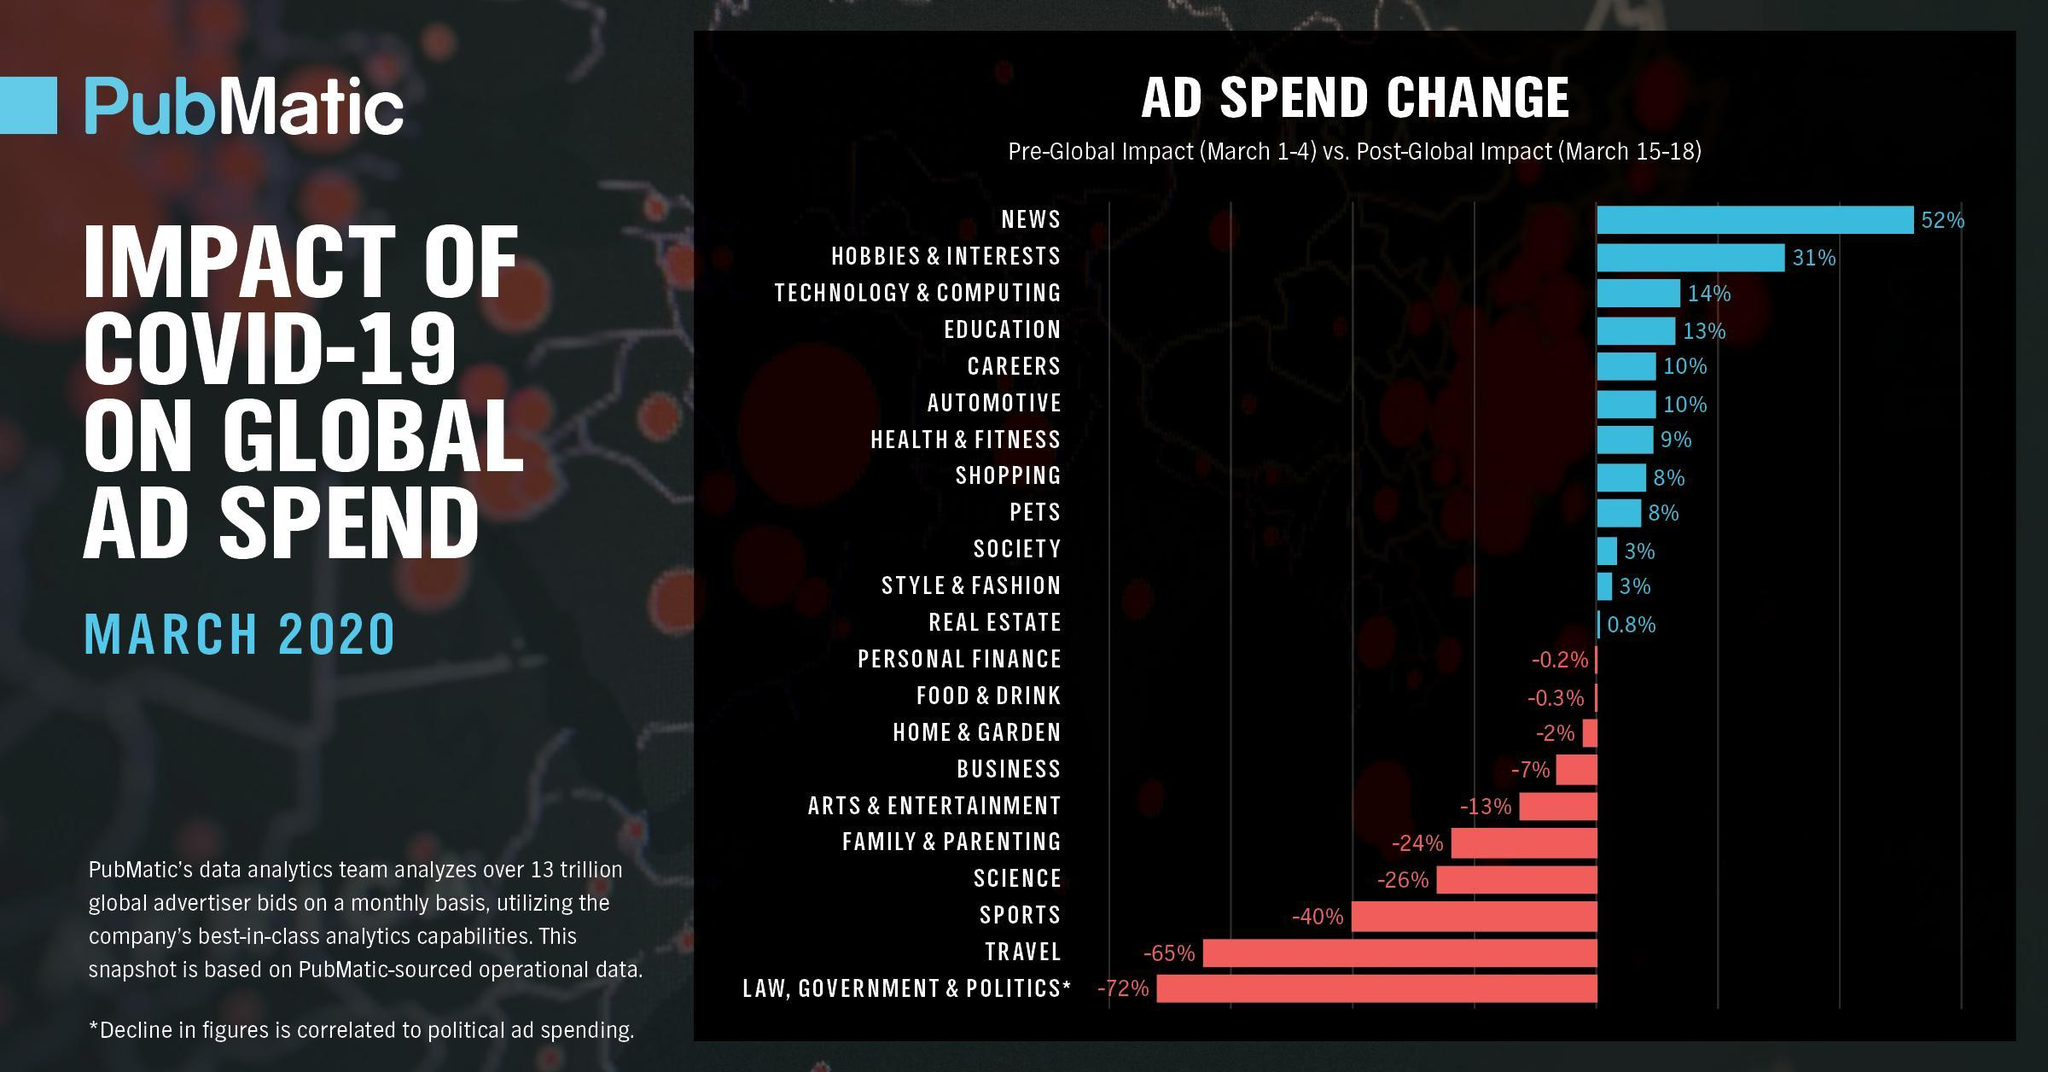What percent was spent on education and careers?
Answer the question with a short phrase. 23% 